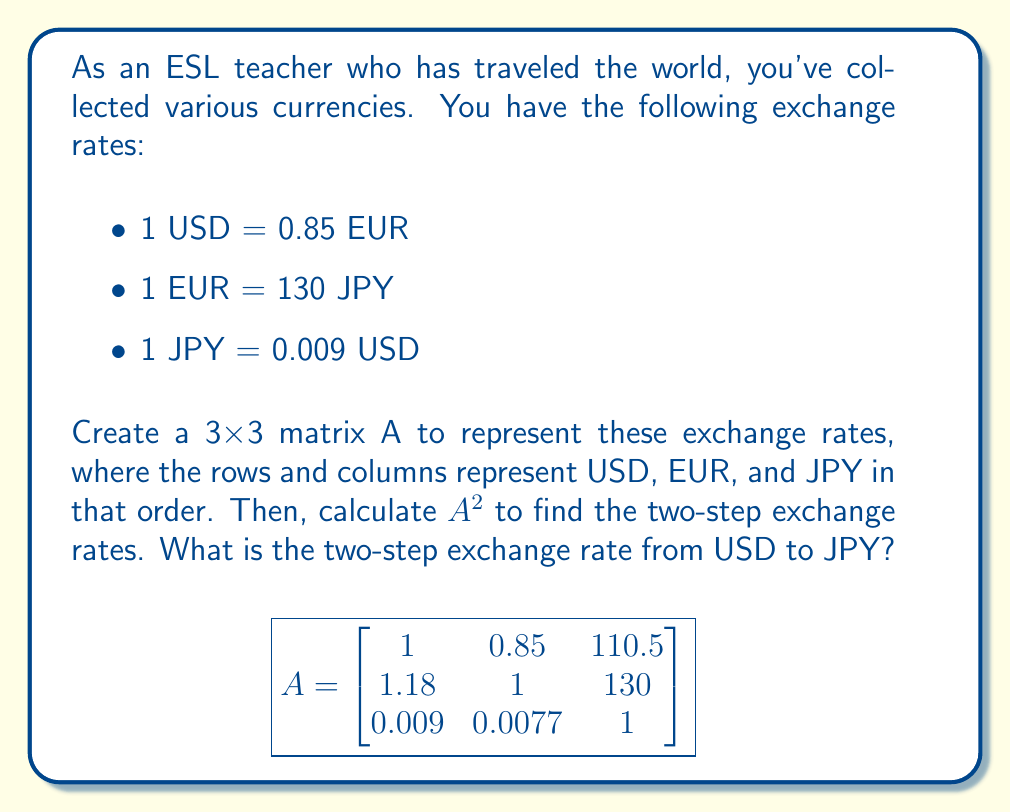Solve this math problem. Let's approach this step-by-step:

1) First, we need to understand what the matrix A represents:
   - $a_{ij}$ represents the exchange rate from currency i to currency j
   - For example, $a_{12} = 0.85$ means 1 USD = 0.85 EUR

2) We're asked to calculate $A^2$, which means we need to multiply A by itself:

   $$A^2 = A \times A$$

3) To multiply these 3x3 matrices, we'll use the standard matrix multiplication formula:

   $$(A^2)_{ij} = \sum_{k=1}^3 a_{ik} \times a_{kj}$$

4) Let's focus on calculating $(A^2)_{13}$, which represents the two-step exchange rate from USD to JPY:

   $(A^2)_{13} = (1 \times 110.5) + (0.85 \times 130) + (110.5 \times 1)$

5) Let's calculate this:
   
   $(A^2)_{13} = 110.5 + 110.5 + 110.5 = 331.5$

6) This means that after two conversions, 1 USD would be equivalent to 331.5 JPY.

Note: The other elements of $A^2$ can be calculated similarly, but we're only asked about the USD to JPY rate.
Answer: 331.5 JPY 